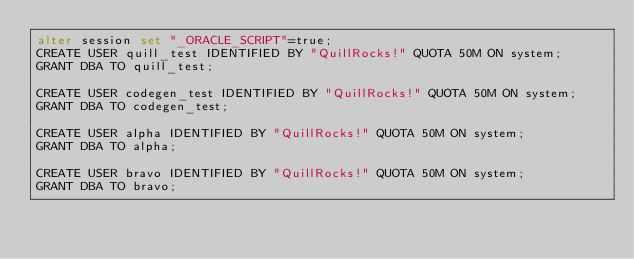Convert code to text. <code><loc_0><loc_0><loc_500><loc_500><_SQL_>alter session set "_ORACLE_SCRIPT"=true;
CREATE USER quill_test IDENTIFIED BY "QuillRocks!" QUOTA 50M ON system;
GRANT DBA TO quill_test;

CREATE USER codegen_test IDENTIFIED BY "QuillRocks!" QUOTA 50M ON system;
GRANT DBA TO codegen_test;

CREATE USER alpha IDENTIFIED BY "QuillRocks!" QUOTA 50M ON system;
GRANT DBA TO alpha;

CREATE USER bravo IDENTIFIED BY "QuillRocks!" QUOTA 50M ON system;
GRANT DBA TO bravo;
</code> 